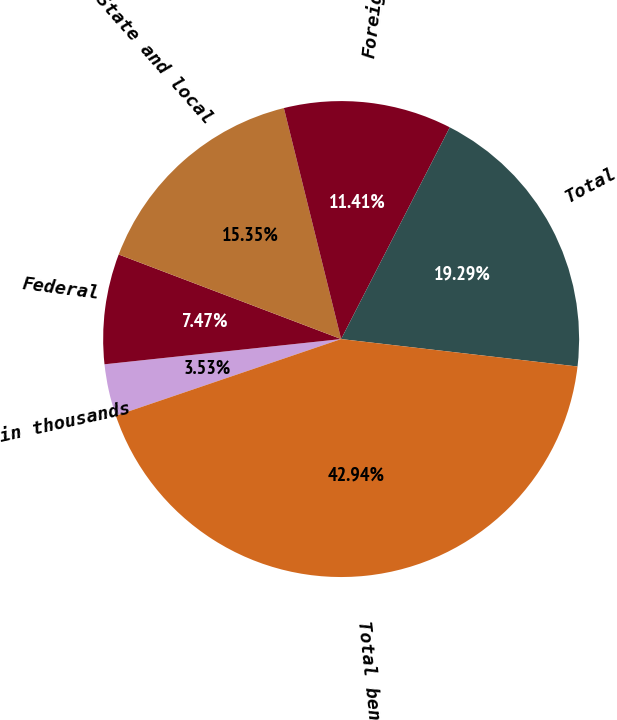<chart> <loc_0><loc_0><loc_500><loc_500><pie_chart><fcel>in thousands<fcel>Federal<fcel>State and local<fcel>Foreign<fcel>Total<fcel>Total benefit<nl><fcel>3.53%<fcel>7.47%<fcel>15.35%<fcel>11.41%<fcel>19.29%<fcel>42.93%<nl></chart> 